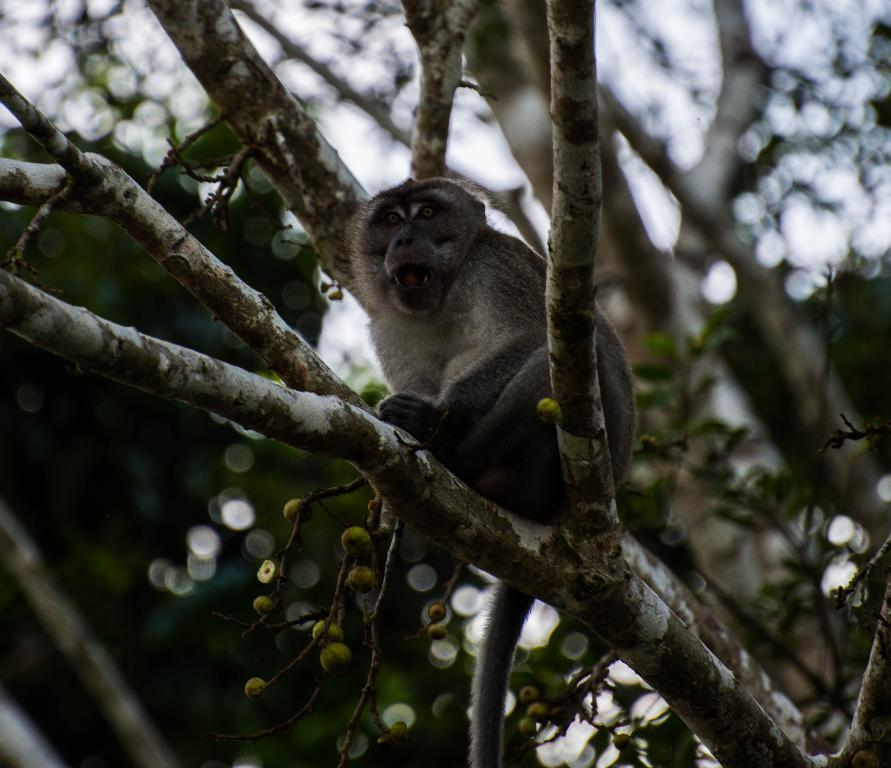What animal can be seen in the image? There is a monkey on a tree branch in the image. What is the monkey holding or eating in the image? There are fruits visible in the image that the monkey might be holding or eating. What can be seen in the sky in the image? The sky is visible in the image. What type of vegetation is present in the background of the image? There are other trees in the background of the image. How is the background of the image depicted? The background is blurred in the image. What type of pen is the monkey using to draw in the image? There is no pen present in the image, and the monkey is not drawing. 